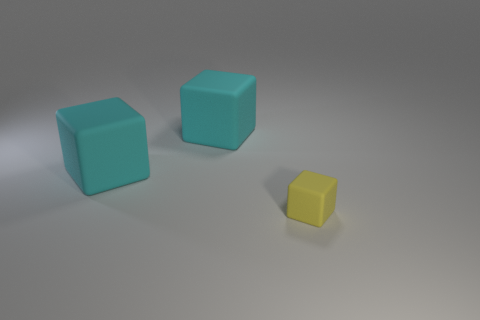What color is the small thing?
Keep it short and to the point. Yellow. Is the number of big cyan rubber blocks behind the small object less than the number of green rubber cylinders?
Offer a very short reply. No. Is there a cyan matte cube?
Ensure brevity in your answer.  Yes. What number of other things are there of the same shape as the tiny yellow thing?
Offer a terse response. 2. What number of cylinders are either small yellow matte things or large cyan things?
Your answer should be very brief. 0. How many other objects are there of the same size as the yellow block?
Provide a short and direct response. 0. What number of yellow things are either big objects or blocks?
Offer a very short reply. 1. What number of large cyan cubes have the same material as the small thing?
Your response must be concise. 2. There is a tiny object; are there any objects behind it?
Ensure brevity in your answer.  Yes. Are there any other yellow rubber objects that have the same shape as the small yellow rubber object?
Keep it short and to the point. No. 